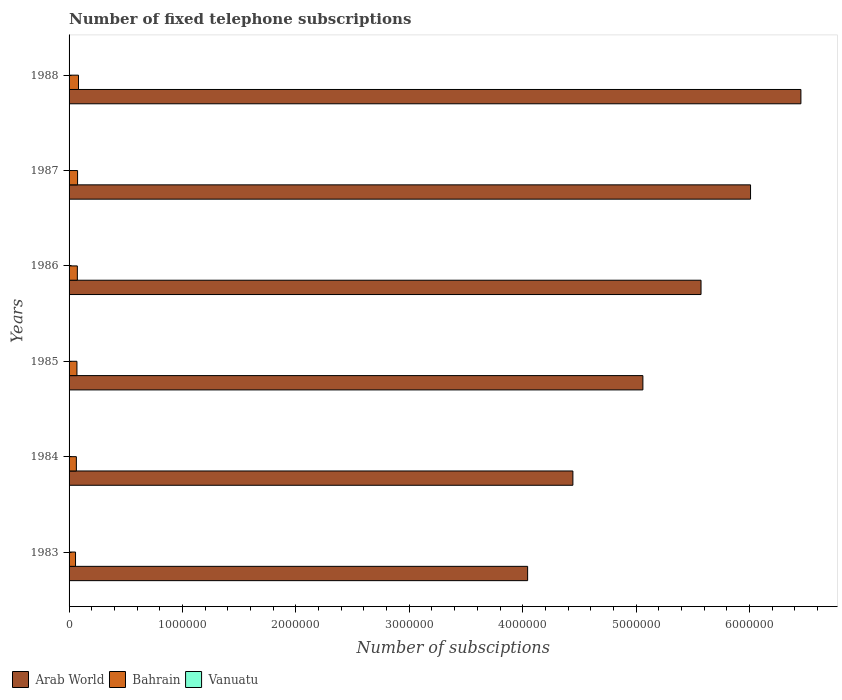How many groups of bars are there?
Provide a short and direct response. 6. Are the number of bars per tick equal to the number of legend labels?
Keep it short and to the point. Yes. How many bars are there on the 1st tick from the bottom?
Give a very brief answer. 3. What is the number of fixed telephone subscriptions in Arab World in 1987?
Give a very brief answer. 6.01e+06. Across all years, what is the maximum number of fixed telephone subscriptions in Bahrain?
Provide a succinct answer. 8.30e+04. Across all years, what is the minimum number of fixed telephone subscriptions in Bahrain?
Offer a very short reply. 5.70e+04. In which year was the number of fixed telephone subscriptions in Bahrain minimum?
Your answer should be very brief. 1983. What is the total number of fixed telephone subscriptions in Bahrain in the graph?
Your answer should be compact. 4.22e+05. What is the difference between the number of fixed telephone subscriptions in Arab World in 1983 and that in 1988?
Your answer should be very brief. -2.41e+06. What is the difference between the number of fixed telephone subscriptions in Arab World in 1983 and the number of fixed telephone subscriptions in Vanuatu in 1984?
Give a very brief answer. 4.04e+06. What is the average number of fixed telephone subscriptions in Arab World per year?
Make the answer very short. 5.26e+06. In the year 1984, what is the difference between the number of fixed telephone subscriptions in Vanuatu and number of fixed telephone subscriptions in Bahrain?
Your answer should be compact. -6.25e+04. What is the ratio of the number of fixed telephone subscriptions in Bahrain in 1983 to that in 1986?
Offer a terse response. 0.78. What is the difference between the highest and the second highest number of fixed telephone subscriptions in Vanuatu?
Your answer should be very brief. 100. What is the difference between the highest and the lowest number of fixed telephone subscriptions in Vanuatu?
Ensure brevity in your answer.  733. Is the sum of the number of fixed telephone subscriptions in Vanuatu in 1986 and 1988 greater than the maximum number of fixed telephone subscriptions in Bahrain across all years?
Provide a short and direct response. No. What does the 2nd bar from the top in 1983 represents?
Provide a succinct answer. Bahrain. What does the 3rd bar from the bottom in 1985 represents?
Make the answer very short. Vanuatu. Is it the case that in every year, the sum of the number of fixed telephone subscriptions in Vanuatu and number of fixed telephone subscriptions in Bahrain is greater than the number of fixed telephone subscriptions in Arab World?
Ensure brevity in your answer.  No. How many bars are there?
Keep it short and to the point. 18. Are all the bars in the graph horizontal?
Keep it short and to the point. Yes. How many years are there in the graph?
Provide a succinct answer. 6. What is the difference between two consecutive major ticks on the X-axis?
Your answer should be very brief. 1.00e+06. How many legend labels are there?
Offer a terse response. 3. What is the title of the graph?
Make the answer very short. Number of fixed telephone subscriptions. Does "St. Vincent and the Grenadines" appear as one of the legend labels in the graph?
Keep it short and to the point. No. What is the label or title of the X-axis?
Make the answer very short. Number of subsciptions. What is the label or title of the Y-axis?
Your answer should be very brief. Years. What is the Number of subsciptions of Arab World in 1983?
Your answer should be very brief. 4.04e+06. What is the Number of subsciptions of Bahrain in 1983?
Provide a succinct answer. 5.70e+04. What is the Number of subsciptions in Vanuatu in 1983?
Keep it short and to the point. 1733. What is the Number of subsciptions of Arab World in 1984?
Offer a terse response. 4.44e+06. What is the Number of subsciptions of Bahrain in 1984?
Offer a very short reply. 6.43e+04. What is the Number of subsciptions of Vanuatu in 1984?
Your answer should be very brief. 1787. What is the Number of subsciptions in Arab World in 1985?
Provide a succinct answer. 5.06e+06. What is the Number of subsciptions of Bahrain in 1985?
Ensure brevity in your answer.  6.93e+04. What is the Number of subsciptions of Vanuatu in 1985?
Your response must be concise. 1567. What is the Number of subsciptions in Arab World in 1986?
Provide a short and direct response. 5.57e+06. What is the Number of subsciptions of Bahrain in 1986?
Your response must be concise. 7.29e+04. What is the Number of subsciptions of Vanuatu in 1986?
Your response must be concise. 2047. What is the Number of subsciptions of Arab World in 1987?
Offer a terse response. 6.01e+06. What is the Number of subsciptions of Bahrain in 1987?
Ensure brevity in your answer.  7.51e+04. What is the Number of subsciptions of Vanuatu in 1987?
Offer a terse response. 2200. What is the Number of subsciptions of Arab World in 1988?
Provide a succinct answer. 6.45e+06. What is the Number of subsciptions of Bahrain in 1988?
Your answer should be very brief. 8.30e+04. What is the Number of subsciptions in Vanuatu in 1988?
Make the answer very short. 2300. Across all years, what is the maximum Number of subsciptions in Arab World?
Keep it short and to the point. 6.45e+06. Across all years, what is the maximum Number of subsciptions in Bahrain?
Provide a short and direct response. 8.30e+04. Across all years, what is the maximum Number of subsciptions of Vanuatu?
Provide a short and direct response. 2300. Across all years, what is the minimum Number of subsciptions of Arab World?
Your answer should be very brief. 4.04e+06. Across all years, what is the minimum Number of subsciptions of Bahrain?
Your answer should be compact. 5.70e+04. Across all years, what is the minimum Number of subsciptions in Vanuatu?
Give a very brief answer. 1567. What is the total Number of subsciptions of Arab World in the graph?
Offer a very short reply. 3.16e+07. What is the total Number of subsciptions in Bahrain in the graph?
Your response must be concise. 4.22e+05. What is the total Number of subsciptions of Vanuatu in the graph?
Your response must be concise. 1.16e+04. What is the difference between the Number of subsciptions of Arab World in 1983 and that in 1984?
Ensure brevity in your answer.  -3.99e+05. What is the difference between the Number of subsciptions in Bahrain in 1983 and that in 1984?
Provide a short and direct response. -7356. What is the difference between the Number of subsciptions in Vanuatu in 1983 and that in 1984?
Your answer should be compact. -54. What is the difference between the Number of subsciptions of Arab World in 1983 and that in 1985?
Make the answer very short. -1.02e+06. What is the difference between the Number of subsciptions in Bahrain in 1983 and that in 1985?
Offer a very short reply. -1.23e+04. What is the difference between the Number of subsciptions in Vanuatu in 1983 and that in 1985?
Offer a terse response. 166. What is the difference between the Number of subsciptions in Arab World in 1983 and that in 1986?
Your answer should be compact. -1.53e+06. What is the difference between the Number of subsciptions of Bahrain in 1983 and that in 1986?
Provide a short and direct response. -1.59e+04. What is the difference between the Number of subsciptions in Vanuatu in 1983 and that in 1986?
Your answer should be very brief. -314. What is the difference between the Number of subsciptions of Arab World in 1983 and that in 1987?
Your answer should be compact. -1.97e+06. What is the difference between the Number of subsciptions in Bahrain in 1983 and that in 1987?
Your answer should be very brief. -1.81e+04. What is the difference between the Number of subsciptions in Vanuatu in 1983 and that in 1987?
Ensure brevity in your answer.  -467. What is the difference between the Number of subsciptions in Arab World in 1983 and that in 1988?
Your response must be concise. -2.41e+06. What is the difference between the Number of subsciptions of Bahrain in 1983 and that in 1988?
Make the answer very short. -2.60e+04. What is the difference between the Number of subsciptions of Vanuatu in 1983 and that in 1988?
Offer a terse response. -567. What is the difference between the Number of subsciptions in Arab World in 1984 and that in 1985?
Keep it short and to the point. -6.17e+05. What is the difference between the Number of subsciptions of Bahrain in 1984 and that in 1985?
Your answer should be compact. -4967. What is the difference between the Number of subsciptions of Vanuatu in 1984 and that in 1985?
Give a very brief answer. 220. What is the difference between the Number of subsciptions of Arab World in 1984 and that in 1986?
Keep it short and to the point. -1.13e+06. What is the difference between the Number of subsciptions of Bahrain in 1984 and that in 1986?
Give a very brief answer. -8577. What is the difference between the Number of subsciptions in Vanuatu in 1984 and that in 1986?
Provide a succinct answer. -260. What is the difference between the Number of subsciptions of Arab World in 1984 and that in 1987?
Provide a short and direct response. -1.57e+06. What is the difference between the Number of subsciptions of Bahrain in 1984 and that in 1987?
Provide a succinct answer. -1.08e+04. What is the difference between the Number of subsciptions of Vanuatu in 1984 and that in 1987?
Give a very brief answer. -413. What is the difference between the Number of subsciptions of Arab World in 1984 and that in 1988?
Offer a terse response. -2.01e+06. What is the difference between the Number of subsciptions of Bahrain in 1984 and that in 1988?
Your answer should be compact. -1.87e+04. What is the difference between the Number of subsciptions of Vanuatu in 1984 and that in 1988?
Offer a terse response. -513. What is the difference between the Number of subsciptions of Arab World in 1985 and that in 1986?
Your response must be concise. -5.13e+05. What is the difference between the Number of subsciptions in Bahrain in 1985 and that in 1986?
Keep it short and to the point. -3610. What is the difference between the Number of subsciptions in Vanuatu in 1985 and that in 1986?
Ensure brevity in your answer.  -480. What is the difference between the Number of subsciptions in Arab World in 1985 and that in 1987?
Your answer should be very brief. -9.49e+05. What is the difference between the Number of subsciptions of Bahrain in 1985 and that in 1987?
Offer a very short reply. -5783. What is the difference between the Number of subsciptions of Vanuatu in 1985 and that in 1987?
Provide a short and direct response. -633. What is the difference between the Number of subsciptions in Arab World in 1985 and that in 1988?
Your answer should be compact. -1.39e+06. What is the difference between the Number of subsciptions of Bahrain in 1985 and that in 1988?
Keep it short and to the point. -1.37e+04. What is the difference between the Number of subsciptions of Vanuatu in 1985 and that in 1988?
Provide a succinct answer. -733. What is the difference between the Number of subsciptions of Arab World in 1986 and that in 1987?
Make the answer very short. -4.37e+05. What is the difference between the Number of subsciptions of Bahrain in 1986 and that in 1987?
Your answer should be very brief. -2173. What is the difference between the Number of subsciptions of Vanuatu in 1986 and that in 1987?
Give a very brief answer. -153. What is the difference between the Number of subsciptions in Arab World in 1986 and that in 1988?
Make the answer very short. -8.81e+05. What is the difference between the Number of subsciptions in Bahrain in 1986 and that in 1988?
Provide a short and direct response. -1.01e+04. What is the difference between the Number of subsciptions of Vanuatu in 1986 and that in 1988?
Provide a short and direct response. -253. What is the difference between the Number of subsciptions of Arab World in 1987 and that in 1988?
Provide a short and direct response. -4.44e+05. What is the difference between the Number of subsciptions in Bahrain in 1987 and that in 1988?
Your answer should be very brief. -7916. What is the difference between the Number of subsciptions in Vanuatu in 1987 and that in 1988?
Make the answer very short. -100. What is the difference between the Number of subsciptions in Arab World in 1983 and the Number of subsciptions in Bahrain in 1984?
Provide a short and direct response. 3.98e+06. What is the difference between the Number of subsciptions in Arab World in 1983 and the Number of subsciptions in Vanuatu in 1984?
Your answer should be very brief. 4.04e+06. What is the difference between the Number of subsciptions in Bahrain in 1983 and the Number of subsciptions in Vanuatu in 1984?
Your answer should be very brief. 5.52e+04. What is the difference between the Number of subsciptions in Arab World in 1983 and the Number of subsciptions in Bahrain in 1985?
Your answer should be very brief. 3.97e+06. What is the difference between the Number of subsciptions of Arab World in 1983 and the Number of subsciptions of Vanuatu in 1985?
Provide a short and direct response. 4.04e+06. What is the difference between the Number of subsciptions in Bahrain in 1983 and the Number of subsciptions in Vanuatu in 1985?
Your answer should be very brief. 5.54e+04. What is the difference between the Number of subsciptions in Arab World in 1983 and the Number of subsciptions in Bahrain in 1986?
Ensure brevity in your answer.  3.97e+06. What is the difference between the Number of subsciptions in Arab World in 1983 and the Number of subsciptions in Vanuatu in 1986?
Your answer should be compact. 4.04e+06. What is the difference between the Number of subsciptions in Bahrain in 1983 and the Number of subsciptions in Vanuatu in 1986?
Your answer should be very brief. 5.49e+04. What is the difference between the Number of subsciptions of Arab World in 1983 and the Number of subsciptions of Bahrain in 1987?
Your answer should be compact. 3.97e+06. What is the difference between the Number of subsciptions of Arab World in 1983 and the Number of subsciptions of Vanuatu in 1987?
Offer a terse response. 4.04e+06. What is the difference between the Number of subsciptions of Bahrain in 1983 and the Number of subsciptions of Vanuatu in 1987?
Provide a short and direct response. 5.48e+04. What is the difference between the Number of subsciptions in Arab World in 1983 and the Number of subsciptions in Bahrain in 1988?
Your answer should be very brief. 3.96e+06. What is the difference between the Number of subsciptions of Arab World in 1983 and the Number of subsciptions of Vanuatu in 1988?
Keep it short and to the point. 4.04e+06. What is the difference between the Number of subsciptions in Bahrain in 1983 and the Number of subsciptions in Vanuatu in 1988?
Keep it short and to the point. 5.47e+04. What is the difference between the Number of subsciptions in Arab World in 1984 and the Number of subsciptions in Bahrain in 1985?
Your answer should be compact. 4.37e+06. What is the difference between the Number of subsciptions in Arab World in 1984 and the Number of subsciptions in Vanuatu in 1985?
Keep it short and to the point. 4.44e+06. What is the difference between the Number of subsciptions in Bahrain in 1984 and the Number of subsciptions in Vanuatu in 1985?
Ensure brevity in your answer.  6.28e+04. What is the difference between the Number of subsciptions in Arab World in 1984 and the Number of subsciptions in Bahrain in 1986?
Your answer should be very brief. 4.37e+06. What is the difference between the Number of subsciptions of Arab World in 1984 and the Number of subsciptions of Vanuatu in 1986?
Provide a short and direct response. 4.44e+06. What is the difference between the Number of subsciptions of Bahrain in 1984 and the Number of subsciptions of Vanuatu in 1986?
Offer a very short reply. 6.23e+04. What is the difference between the Number of subsciptions of Arab World in 1984 and the Number of subsciptions of Bahrain in 1987?
Ensure brevity in your answer.  4.37e+06. What is the difference between the Number of subsciptions in Arab World in 1984 and the Number of subsciptions in Vanuatu in 1987?
Ensure brevity in your answer.  4.44e+06. What is the difference between the Number of subsciptions of Bahrain in 1984 and the Number of subsciptions of Vanuatu in 1987?
Provide a short and direct response. 6.21e+04. What is the difference between the Number of subsciptions of Arab World in 1984 and the Number of subsciptions of Bahrain in 1988?
Your answer should be very brief. 4.36e+06. What is the difference between the Number of subsciptions in Arab World in 1984 and the Number of subsciptions in Vanuatu in 1988?
Provide a succinct answer. 4.44e+06. What is the difference between the Number of subsciptions of Bahrain in 1984 and the Number of subsciptions of Vanuatu in 1988?
Your answer should be very brief. 6.20e+04. What is the difference between the Number of subsciptions in Arab World in 1985 and the Number of subsciptions in Bahrain in 1986?
Your answer should be compact. 4.99e+06. What is the difference between the Number of subsciptions of Arab World in 1985 and the Number of subsciptions of Vanuatu in 1986?
Ensure brevity in your answer.  5.06e+06. What is the difference between the Number of subsciptions in Bahrain in 1985 and the Number of subsciptions in Vanuatu in 1986?
Ensure brevity in your answer.  6.72e+04. What is the difference between the Number of subsciptions of Arab World in 1985 and the Number of subsciptions of Bahrain in 1987?
Your response must be concise. 4.98e+06. What is the difference between the Number of subsciptions in Arab World in 1985 and the Number of subsciptions in Vanuatu in 1987?
Give a very brief answer. 5.06e+06. What is the difference between the Number of subsciptions of Bahrain in 1985 and the Number of subsciptions of Vanuatu in 1987?
Offer a very short reply. 6.71e+04. What is the difference between the Number of subsciptions in Arab World in 1985 and the Number of subsciptions in Bahrain in 1988?
Make the answer very short. 4.98e+06. What is the difference between the Number of subsciptions of Arab World in 1985 and the Number of subsciptions of Vanuatu in 1988?
Your answer should be compact. 5.06e+06. What is the difference between the Number of subsciptions in Bahrain in 1985 and the Number of subsciptions in Vanuatu in 1988?
Ensure brevity in your answer.  6.70e+04. What is the difference between the Number of subsciptions in Arab World in 1986 and the Number of subsciptions in Bahrain in 1987?
Your response must be concise. 5.50e+06. What is the difference between the Number of subsciptions of Arab World in 1986 and the Number of subsciptions of Vanuatu in 1987?
Your answer should be compact. 5.57e+06. What is the difference between the Number of subsciptions of Bahrain in 1986 and the Number of subsciptions of Vanuatu in 1987?
Your answer should be compact. 7.07e+04. What is the difference between the Number of subsciptions of Arab World in 1986 and the Number of subsciptions of Bahrain in 1988?
Give a very brief answer. 5.49e+06. What is the difference between the Number of subsciptions of Arab World in 1986 and the Number of subsciptions of Vanuatu in 1988?
Give a very brief answer. 5.57e+06. What is the difference between the Number of subsciptions of Bahrain in 1986 and the Number of subsciptions of Vanuatu in 1988?
Provide a succinct answer. 7.06e+04. What is the difference between the Number of subsciptions in Arab World in 1987 and the Number of subsciptions in Bahrain in 1988?
Provide a succinct answer. 5.93e+06. What is the difference between the Number of subsciptions in Arab World in 1987 and the Number of subsciptions in Vanuatu in 1988?
Your answer should be very brief. 6.01e+06. What is the difference between the Number of subsciptions of Bahrain in 1987 and the Number of subsciptions of Vanuatu in 1988?
Provide a short and direct response. 7.28e+04. What is the average Number of subsciptions of Arab World per year?
Offer a terse response. 5.26e+06. What is the average Number of subsciptions of Bahrain per year?
Offer a very short reply. 7.03e+04. What is the average Number of subsciptions of Vanuatu per year?
Offer a terse response. 1939. In the year 1983, what is the difference between the Number of subsciptions of Arab World and Number of subsciptions of Bahrain?
Give a very brief answer. 3.99e+06. In the year 1983, what is the difference between the Number of subsciptions in Arab World and Number of subsciptions in Vanuatu?
Your answer should be very brief. 4.04e+06. In the year 1983, what is the difference between the Number of subsciptions of Bahrain and Number of subsciptions of Vanuatu?
Make the answer very short. 5.52e+04. In the year 1984, what is the difference between the Number of subsciptions of Arab World and Number of subsciptions of Bahrain?
Provide a short and direct response. 4.38e+06. In the year 1984, what is the difference between the Number of subsciptions in Arab World and Number of subsciptions in Vanuatu?
Your answer should be compact. 4.44e+06. In the year 1984, what is the difference between the Number of subsciptions of Bahrain and Number of subsciptions of Vanuatu?
Make the answer very short. 6.25e+04. In the year 1985, what is the difference between the Number of subsciptions of Arab World and Number of subsciptions of Bahrain?
Offer a very short reply. 4.99e+06. In the year 1985, what is the difference between the Number of subsciptions in Arab World and Number of subsciptions in Vanuatu?
Make the answer very short. 5.06e+06. In the year 1985, what is the difference between the Number of subsciptions in Bahrain and Number of subsciptions in Vanuatu?
Your response must be concise. 6.77e+04. In the year 1986, what is the difference between the Number of subsciptions of Arab World and Number of subsciptions of Bahrain?
Keep it short and to the point. 5.50e+06. In the year 1986, what is the difference between the Number of subsciptions in Arab World and Number of subsciptions in Vanuatu?
Offer a very short reply. 5.57e+06. In the year 1986, what is the difference between the Number of subsciptions of Bahrain and Number of subsciptions of Vanuatu?
Your answer should be very brief. 7.09e+04. In the year 1987, what is the difference between the Number of subsciptions in Arab World and Number of subsciptions in Bahrain?
Give a very brief answer. 5.93e+06. In the year 1987, what is the difference between the Number of subsciptions in Arab World and Number of subsciptions in Vanuatu?
Your answer should be very brief. 6.01e+06. In the year 1987, what is the difference between the Number of subsciptions of Bahrain and Number of subsciptions of Vanuatu?
Provide a short and direct response. 7.29e+04. In the year 1988, what is the difference between the Number of subsciptions in Arab World and Number of subsciptions in Bahrain?
Provide a succinct answer. 6.37e+06. In the year 1988, what is the difference between the Number of subsciptions of Arab World and Number of subsciptions of Vanuatu?
Your response must be concise. 6.45e+06. In the year 1988, what is the difference between the Number of subsciptions of Bahrain and Number of subsciptions of Vanuatu?
Offer a very short reply. 8.07e+04. What is the ratio of the Number of subsciptions of Arab World in 1983 to that in 1984?
Give a very brief answer. 0.91. What is the ratio of the Number of subsciptions in Bahrain in 1983 to that in 1984?
Give a very brief answer. 0.89. What is the ratio of the Number of subsciptions of Vanuatu in 1983 to that in 1984?
Provide a short and direct response. 0.97. What is the ratio of the Number of subsciptions of Arab World in 1983 to that in 1985?
Ensure brevity in your answer.  0.8. What is the ratio of the Number of subsciptions in Bahrain in 1983 to that in 1985?
Provide a succinct answer. 0.82. What is the ratio of the Number of subsciptions in Vanuatu in 1983 to that in 1985?
Provide a succinct answer. 1.11. What is the ratio of the Number of subsciptions in Arab World in 1983 to that in 1986?
Your answer should be compact. 0.73. What is the ratio of the Number of subsciptions in Bahrain in 1983 to that in 1986?
Keep it short and to the point. 0.78. What is the ratio of the Number of subsciptions in Vanuatu in 1983 to that in 1986?
Your response must be concise. 0.85. What is the ratio of the Number of subsciptions of Arab World in 1983 to that in 1987?
Provide a short and direct response. 0.67. What is the ratio of the Number of subsciptions of Bahrain in 1983 to that in 1987?
Make the answer very short. 0.76. What is the ratio of the Number of subsciptions of Vanuatu in 1983 to that in 1987?
Provide a short and direct response. 0.79. What is the ratio of the Number of subsciptions in Arab World in 1983 to that in 1988?
Your answer should be compact. 0.63. What is the ratio of the Number of subsciptions of Bahrain in 1983 to that in 1988?
Offer a terse response. 0.69. What is the ratio of the Number of subsciptions of Vanuatu in 1983 to that in 1988?
Your response must be concise. 0.75. What is the ratio of the Number of subsciptions in Arab World in 1984 to that in 1985?
Provide a succinct answer. 0.88. What is the ratio of the Number of subsciptions in Bahrain in 1984 to that in 1985?
Provide a short and direct response. 0.93. What is the ratio of the Number of subsciptions in Vanuatu in 1984 to that in 1985?
Give a very brief answer. 1.14. What is the ratio of the Number of subsciptions of Arab World in 1984 to that in 1986?
Ensure brevity in your answer.  0.8. What is the ratio of the Number of subsciptions of Bahrain in 1984 to that in 1986?
Make the answer very short. 0.88. What is the ratio of the Number of subsciptions of Vanuatu in 1984 to that in 1986?
Provide a succinct answer. 0.87. What is the ratio of the Number of subsciptions of Arab World in 1984 to that in 1987?
Your answer should be very brief. 0.74. What is the ratio of the Number of subsciptions in Bahrain in 1984 to that in 1987?
Give a very brief answer. 0.86. What is the ratio of the Number of subsciptions of Vanuatu in 1984 to that in 1987?
Your response must be concise. 0.81. What is the ratio of the Number of subsciptions of Arab World in 1984 to that in 1988?
Keep it short and to the point. 0.69. What is the ratio of the Number of subsciptions in Bahrain in 1984 to that in 1988?
Give a very brief answer. 0.78. What is the ratio of the Number of subsciptions in Vanuatu in 1984 to that in 1988?
Provide a succinct answer. 0.78. What is the ratio of the Number of subsciptions of Arab World in 1985 to that in 1986?
Your response must be concise. 0.91. What is the ratio of the Number of subsciptions of Bahrain in 1985 to that in 1986?
Ensure brevity in your answer.  0.95. What is the ratio of the Number of subsciptions of Vanuatu in 1985 to that in 1986?
Make the answer very short. 0.77. What is the ratio of the Number of subsciptions of Arab World in 1985 to that in 1987?
Provide a short and direct response. 0.84. What is the ratio of the Number of subsciptions of Bahrain in 1985 to that in 1987?
Give a very brief answer. 0.92. What is the ratio of the Number of subsciptions of Vanuatu in 1985 to that in 1987?
Ensure brevity in your answer.  0.71. What is the ratio of the Number of subsciptions of Arab World in 1985 to that in 1988?
Your answer should be compact. 0.78. What is the ratio of the Number of subsciptions in Bahrain in 1985 to that in 1988?
Ensure brevity in your answer.  0.83. What is the ratio of the Number of subsciptions in Vanuatu in 1985 to that in 1988?
Provide a short and direct response. 0.68. What is the ratio of the Number of subsciptions in Arab World in 1986 to that in 1987?
Provide a succinct answer. 0.93. What is the ratio of the Number of subsciptions of Bahrain in 1986 to that in 1987?
Your response must be concise. 0.97. What is the ratio of the Number of subsciptions of Vanuatu in 1986 to that in 1987?
Your answer should be very brief. 0.93. What is the ratio of the Number of subsciptions in Arab World in 1986 to that in 1988?
Offer a terse response. 0.86. What is the ratio of the Number of subsciptions of Bahrain in 1986 to that in 1988?
Make the answer very short. 0.88. What is the ratio of the Number of subsciptions of Vanuatu in 1986 to that in 1988?
Offer a very short reply. 0.89. What is the ratio of the Number of subsciptions of Arab World in 1987 to that in 1988?
Provide a succinct answer. 0.93. What is the ratio of the Number of subsciptions of Bahrain in 1987 to that in 1988?
Provide a short and direct response. 0.9. What is the ratio of the Number of subsciptions in Vanuatu in 1987 to that in 1988?
Your answer should be compact. 0.96. What is the difference between the highest and the second highest Number of subsciptions in Arab World?
Provide a succinct answer. 4.44e+05. What is the difference between the highest and the second highest Number of subsciptions in Bahrain?
Offer a terse response. 7916. What is the difference between the highest and the second highest Number of subsciptions in Vanuatu?
Provide a succinct answer. 100. What is the difference between the highest and the lowest Number of subsciptions in Arab World?
Make the answer very short. 2.41e+06. What is the difference between the highest and the lowest Number of subsciptions of Bahrain?
Make the answer very short. 2.60e+04. What is the difference between the highest and the lowest Number of subsciptions of Vanuatu?
Offer a terse response. 733. 